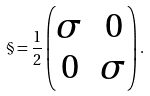Convert formula to latex. <formula><loc_0><loc_0><loc_500><loc_500>{ \S } = \frac { 1 } { 2 } \begin{pmatrix} \sigma & 0 \\ 0 & \sigma \end{pmatrix} .</formula> 